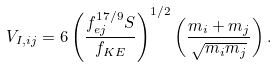<formula> <loc_0><loc_0><loc_500><loc_500>V _ { I , i j } = 6 \left ( \frac { f _ { e j } ^ { 1 7 / 9 } S } { f _ { K E } } \right ) ^ { 1 / 2 } \left ( \frac { m _ { i } + m _ { j } } { \sqrt { m _ { i } m _ { j } } } \right ) .</formula> 